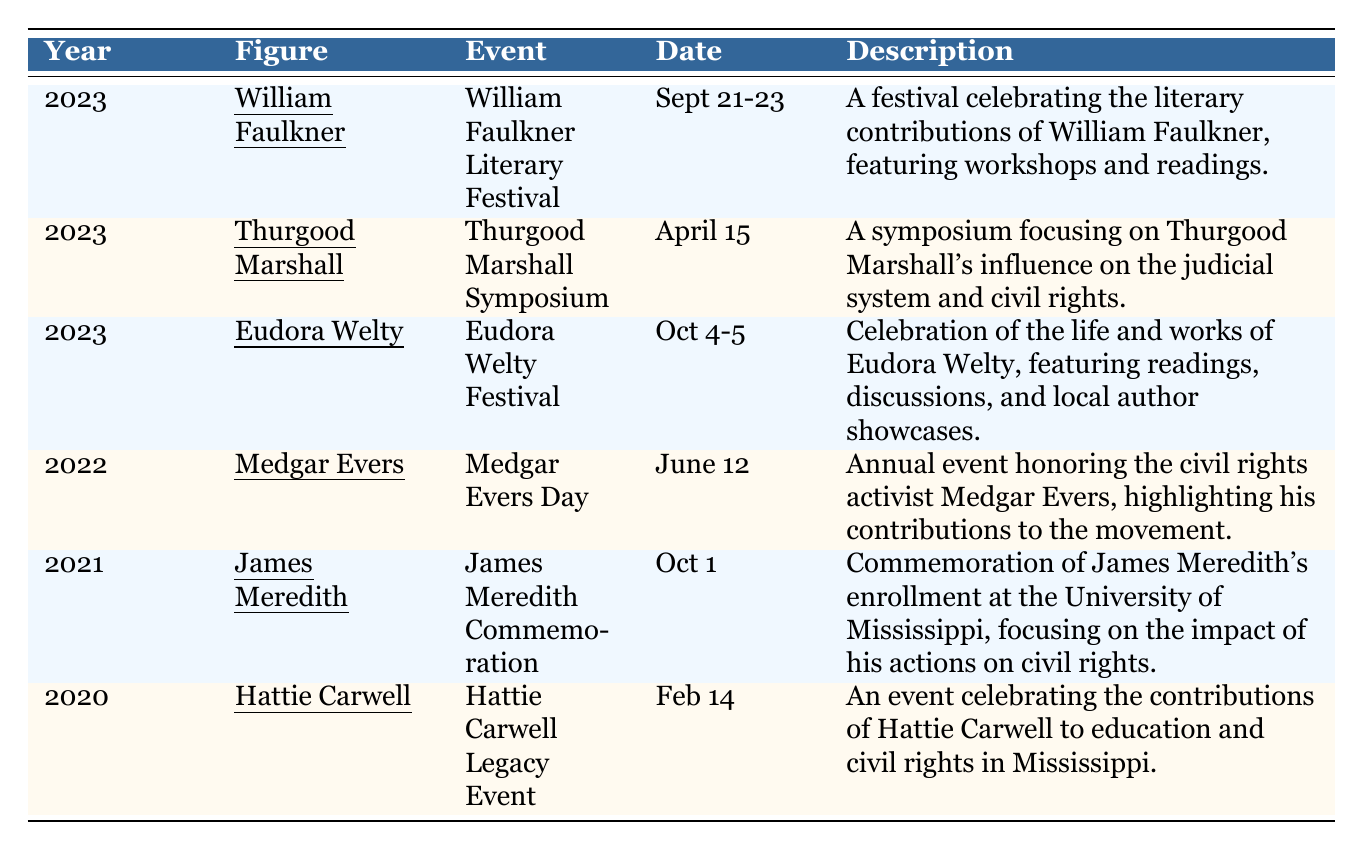What commemorations are scheduled for 2023? There are three commemorations listed for 2023: the William Faulkner Literary Festival, the Thurgood Marshall Symposium, and the Eudora Welty Festival.
Answer: William Faulkner Literary Festival, Thurgood Marshall Symposium, Eudora Welty Festival Who is commemorated on June 12, 2022? The table shows that the event on June 12, 2022, is dedicated to Medgar Evers, which is known as Medgar Evers Day.
Answer: Medgar Evers What is the location of the James Meredith Commemoration? The table indicates that the James Meredith Commemoration takes place in Oxford, MS.
Answer: Oxford, MS How many events are held in Jackson, MS? There are four events listed in the table for Jackson, MS: Medgar Evers Day in 2022, the Thurgood Marshall Symposium in 2023, and the Eudora Welty Festival in 2023.
Answer: 4 Which figure was commemorated in Natchez, MS, and when? The table lists Hattie Carwell as the figure commemorated in Natchez, MS, on February 14, 2020.
Answer: Hattie Carwell, February 14, 2020 Did any commemorations occur in 2020? The table confirms that there was one commemoration in 2020, which was the Hattie Carwell Legacy Event.
Answer: Yes What is the date range for the Eudora Welty Festival? The Eudora Welty Festival is scheduled for October 4-5, 2023, as listed in the table.
Answer: October 4-5, 2023 Which historical figure has the event "Hattie Carwell Legacy Event"? According to the table, the Hattie Carwell Legacy Event is associated with Hattie Carwell.
Answer: Hattie Carwell How many events focused on literary contributions? The table shows that two events focus on literary contributions: the William Faulkner Literary Festival and the Eudora Welty Festival.
Answer: 2 If you had to identify the year with the most commemorations represented in the table, which year would it be? 2023 has the most commemorations with three events listed: the William Faulkner Literary Festival, the Thurgood Marshall Symposium, and the Eudora Welty Festival.
Answer: 2023 In what context was James Meredith commemorated? The table indicates that James Meredith was commemorated for his enrollment at the University of Mississippi, focusing on the civil rights impact.
Answer: Enrollment at the University of Mississippi What is the average number of events per year based on the table? There are six events listed across five years (2020 to 2023), so the average is 6 events / 5 years = 1.2 events per year.
Answer: 1.2 events per year What is the last event listed in the table for 2023? The last event listed for 2023 is the Eudora Welty Festival, which takes place on October 4-5.
Answer: Eudora Welty Festival 